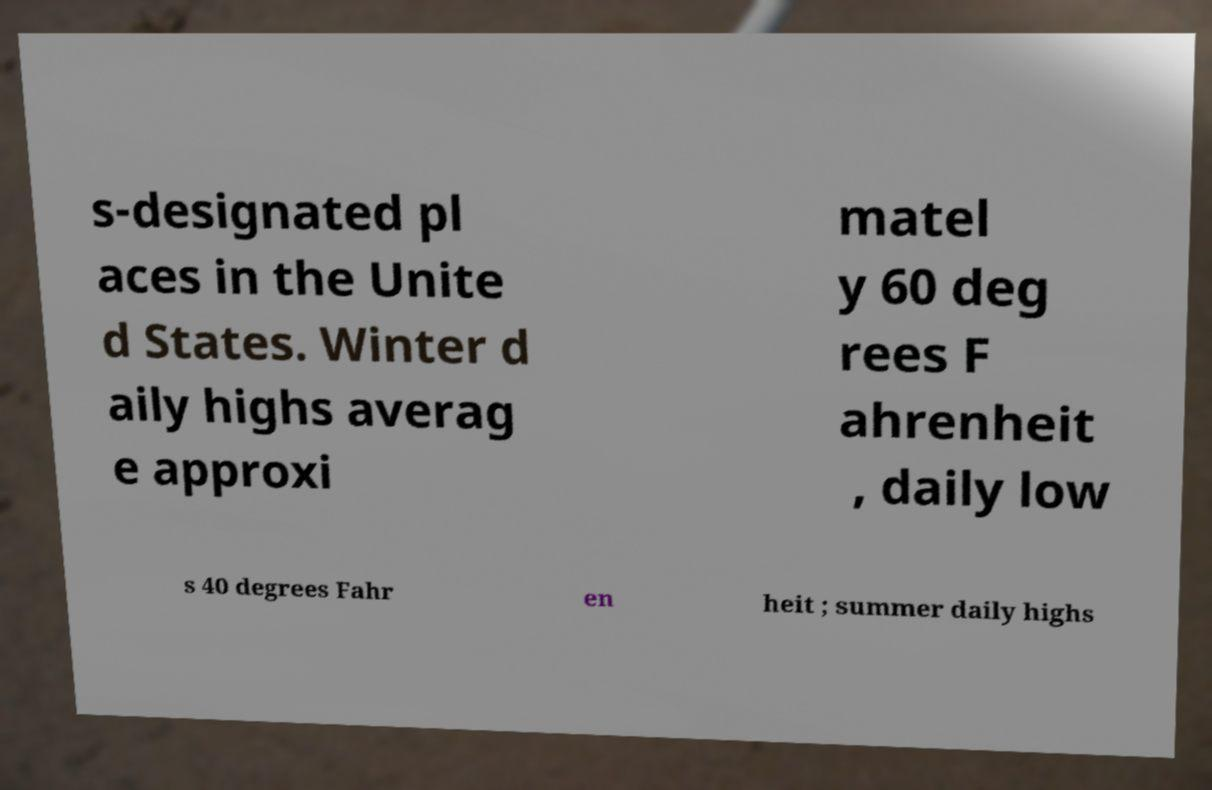There's text embedded in this image that I need extracted. Can you transcribe it verbatim? s-designated pl aces in the Unite d States. Winter d aily highs averag e approxi matel y 60 deg rees F ahrenheit , daily low s 40 degrees Fahr en heit ; summer daily highs 